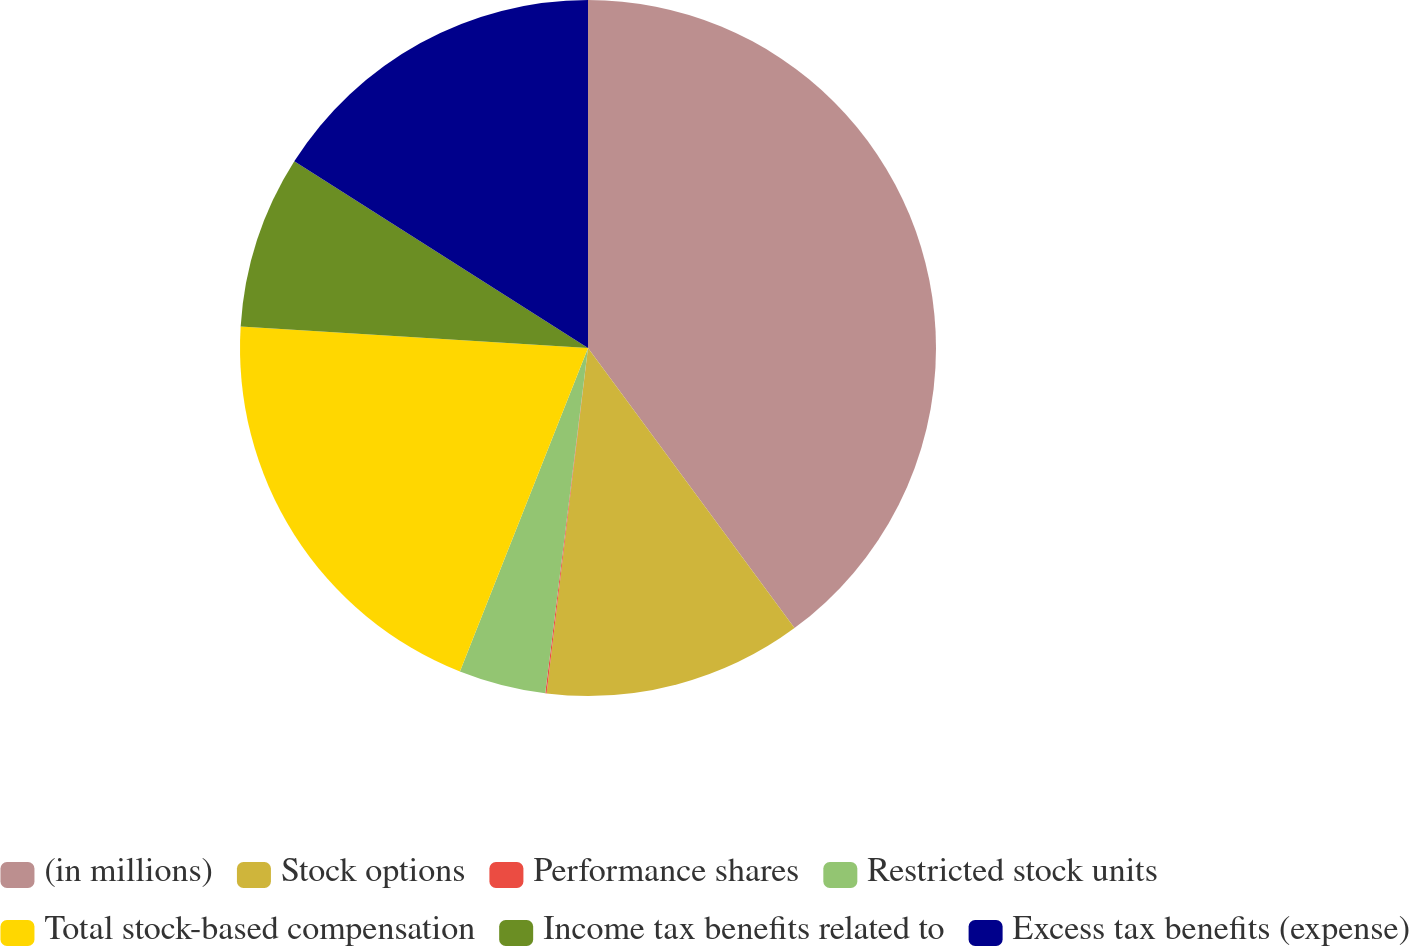Convert chart to OTSL. <chart><loc_0><loc_0><loc_500><loc_500><pie_chart><fcel>(in millions)<fcel>Stock options<fcel>Performance shares<fcel>Restricted stock units<fcel>Total stock-based compensation<fcel>Income tax benefits related to<fcel>Excess tax benefits (expense)<nl><fcel>39.89%<fcel>12.01%<fcel>0.06%<fcel>4.04%<fcel>19.98%<fcel>8.03%<fcel>15.99%<nl></chart> 